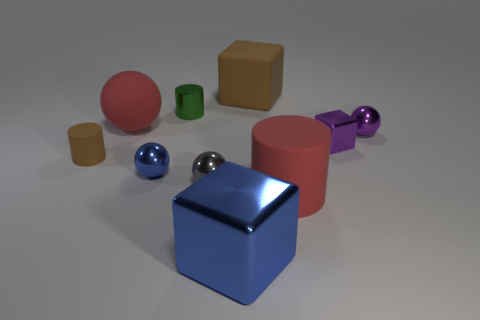How many cylinders are either small brown matte things or large brown things?
Give a very brief answer. 1. There is a big matte thing in front of the cylinder that is left of the tiny green object; are there any small brown matte objects right of it?
Keep it short and to the point. No. What color is the other matte thing that is the same shape as the gray object?
Keep it short and to the point. Red. How many yellow objects are either metallic balls or large spheres?
Ensure brevity in your answer.  0. There is a purple object that is behind the tiny purple object that is in front of the purple ball; what is it made of?
Ensure brevity in your answer.  Metal. Do the tiny brown thing and the small green object have the same shape?
Keep it short and to the point. Yes. There is a cube that is the same size as the brown cylinder; what color is it?
Provide a short and direct response. Purple. Are there any other shiny cylinders that have the same color as the shiny cylinder?
Keep it short and to the point. No. Are any small yellow matte cubes visible?
Provide a short and direct response. No. Is the large red object left of the gray metal thing made of the same material as the small purple ball?
Provide a succinct answer. No. 